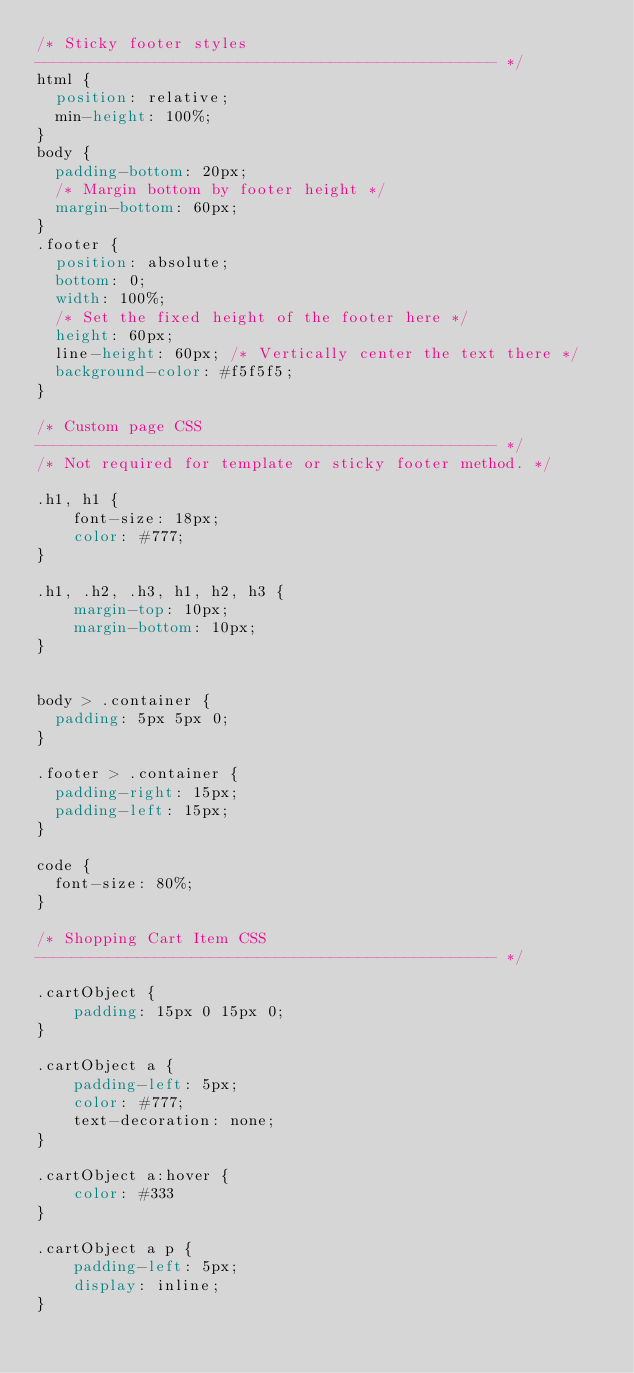<code> <loc_0><loc_0><loc_500><loc_500><_CSS_>/* Sticky footer styles
-------------------------------------------------- */
html {
  position: relative;
  min-height: 100%;
}
body {
  padding-bottom: 20px;
  /* Margin bottom by footer height */
  margin-bottom: 60px;
}
.footer {
  position: absolute;
  bottom: 0;
  width: 100%;
  /* Set the fixed height of the footer here */
  height: 60px;
  line-height: 60px; /* Vertically center the text there */
  background-color: #f5f5f5;
}

/* Custom page CSS
-------------------------------------------------- */
/* Not required for template or sticky footer method. */

.h1, h1 {
    font-size: 18px;
    color: #777;
}

.h1, .h2, .h3, h1, h2, h3 {
    margin-top: 10px;
    margin-bottom: 10px;
}


body > .container {
  padding: 5px 5px 0;
}

.footer > .container {
  padding-right: 15px;
  padding-left: 15px;
}

code {
  font-size: 80%;
}

/* Shopping Cart Item CSS
-------------------------------------------------- */

.cartObject {
    padding: 15px 0 15px 0;
}

.cartObject a {
    padding-left: 5px;
    color: #777;
    text-decoration: none;
}

.cartObject a:hover {
    color: #333
}

.cartObject a p {
    padding-left: 5px;
    display: inline;
}</code> 